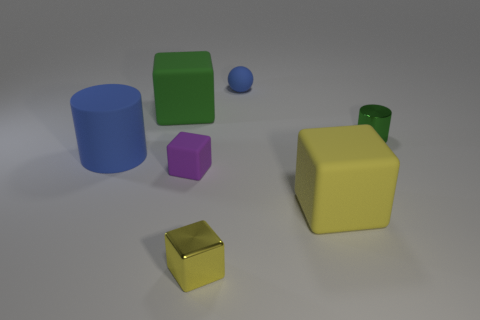Are there more tiny yellow blocks than large brown metallic things?
Give a very brief answer. Yes. What size is the rubber thing that is the same color as the large matte cylinder?
Offer a very short reply. Small. What shape is the blue rubber thing right of the big matte cylinder that is behind the tiny purple thing?
Make the answer very short. Sphere. There is a cylinder that is right of the cylinder in front of the tiny green object; are there any small shiny things that are on the left side of it?
Offer a very short reply. Yes. There is a cylinder that is the same size as the yellow rubber thing; what is its color?
Your response must be concise. Blue. There is a tiny object that is both behind the blue cylinder and in front of the tiny blue sphere; what shape is it?
Make the answer very short. Cylinder. What is the size of the cube behind the blue thing that is in front of the large green rubber block?
Offer a terse response. Large. What number of things have the same color as the metallic cylinder?
Keep it short and to the point. 1. What number of other objects are there of the same size as the matte cylinder?
Offer a very short reply. 2. What size is the thing that is on the right side of the yellow metal thing and in front of the tiny green metal cylinder?
Your answer should be very brief. Large. 